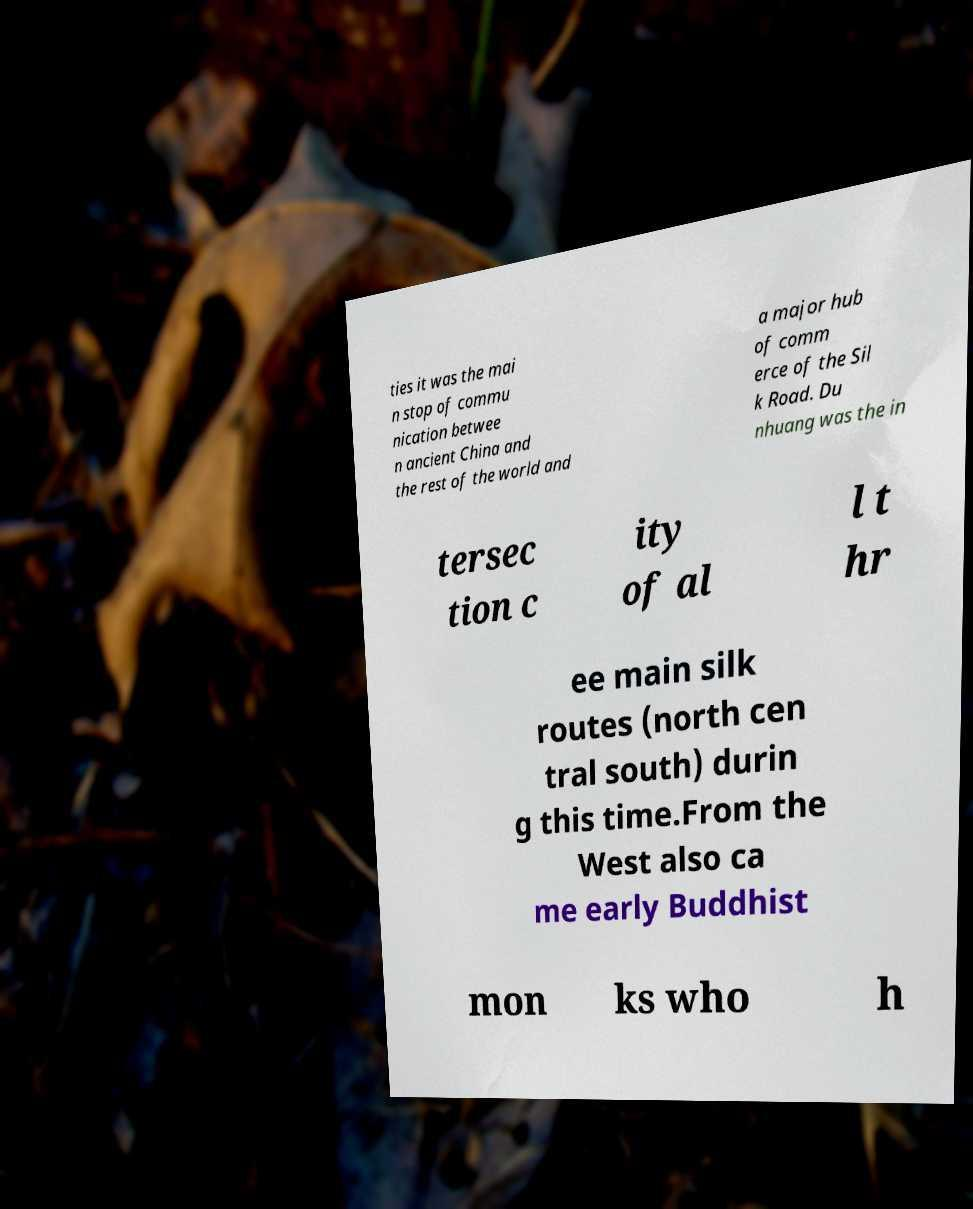Could you extract and type out the text from this image? ties it was the mai n stop of commu nication betwee n ancient China and the rest of the world and a major hub of comm erce of the Sil k Road. Du nhuang was the in tersec tion c ity of al l t hr ee main silk routes (north cen tral south) durin g this time.From the West also ca me early Buddhist mon ks who h 